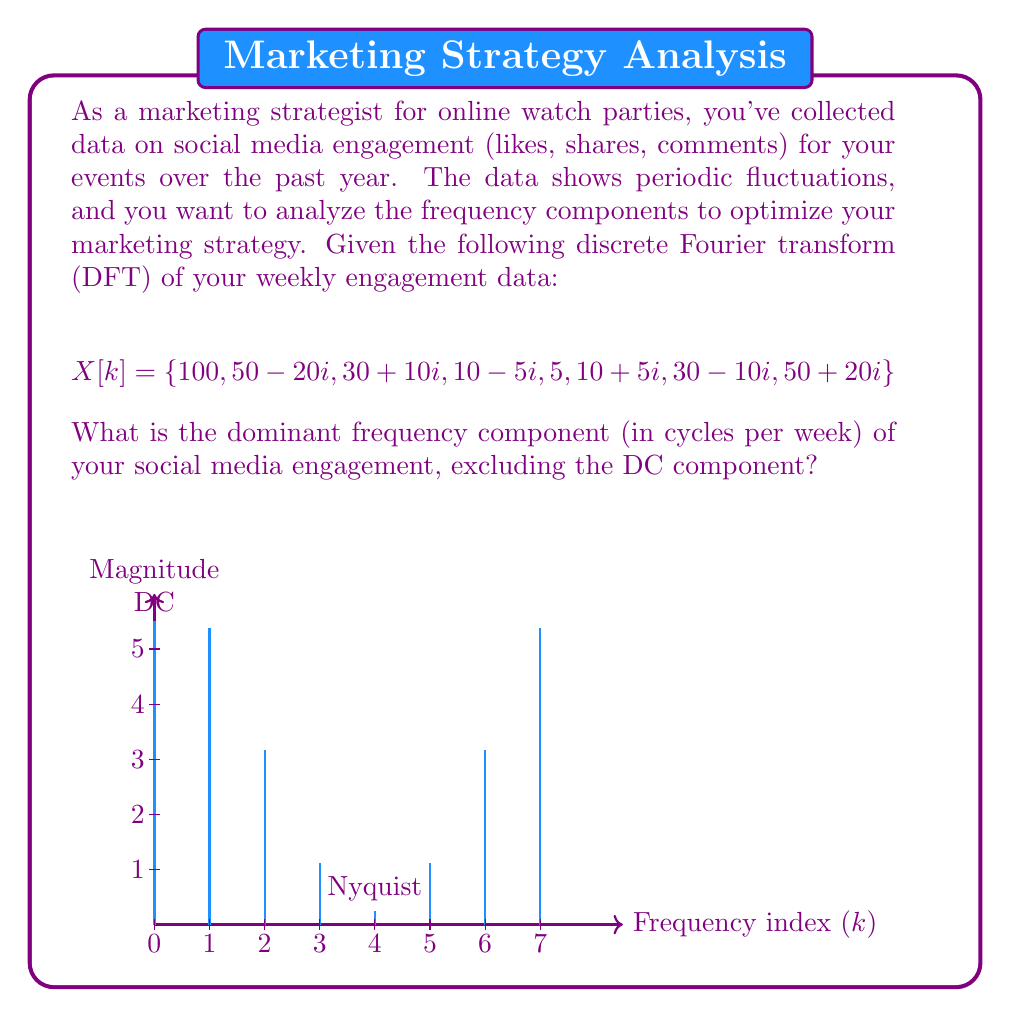Help me with this question. To find the dominant frequency component, we need to follow these steps:

1) Calculate the magnitude of each frequency component:
   $$|X[k]| = \sqrt{\text{Re}(X[k])^2 + \text{Im}(X[k])^2}$$

2) Ignore the DC component (k=0) as it represents the average engagement.

3) Calculate the magnitudes:
   $|X[0]| = 100$ (DC component, ignored)
   $|X[1]| = |X[7]| = \sqrt{50^2 + 20^2} = 53.85$
   $|X[2]| = |X[6]| = \sqrt{30^2 + 10^2} = 31.62$
   $|X[3]| = |X[5]| = \sqrt{10^2 + 5^2} = 11.18$
   $|X[4]| = 5$ (Nyquist frequency)

4) The largest magnitude (excluding DC) is 53.85 at k=1 and k=7.

5) To convert the frequency index to cycles per week:
   $$f = \frac{k}{N} \cdot f_s$$
   where N is the number of samples (8) and $f_s$ is the sampling frequency (1 sample/week).

6) For k=1: $f = \frac{1}{8} \cdot 1 = 0.125$ cycles/week

Therefore, the dominant frequency is 0.125 cycles/week, or a period of 8 weeks.
Answer: 0.125 cycles/week 